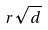Convert formula to latex. <formula><loc_0><loc_0><loc_500><loc_500>r \sqrt { d }</formula> 